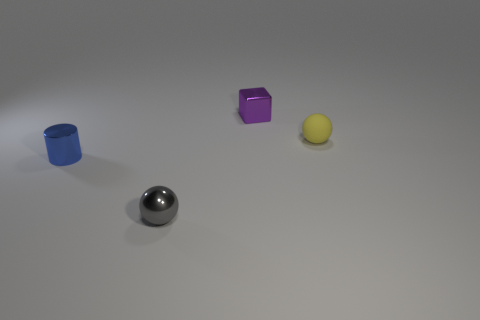Add 3 large gray blocks. How many objects exist? 7 Subtract all cylinders. How many objects are left? 3 Subtract all blue metal blocks. Subtract all gray spheres. How many objects are left? 3 Add 3 small yellow balls. How many small yellow balls are left? 4 Add 1 gray balls. How many gray balls exist? 2 Subtract 1 gray spheres. How many objects are left? 3 